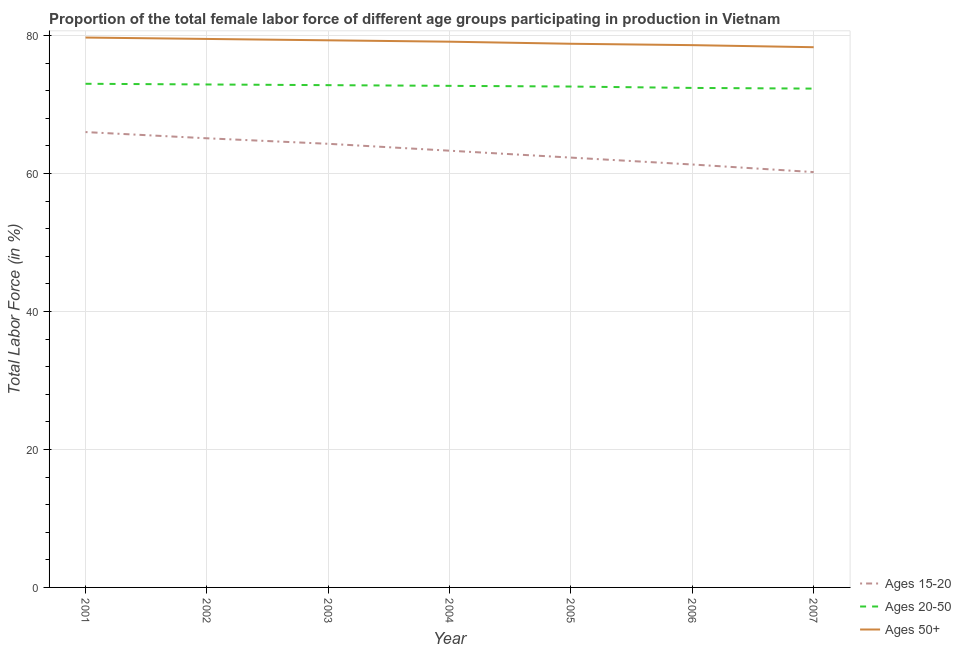How many different coloured lines are there?
Offer a terse response. 3. What is the percentage of female labor force within the age group 15-20 in 2002?
Provide a short and direct response. 65.1. Across all years, what is the maximum percentage of female labor force above age 50?
Your answer should be compact. 79.7. Across all years, what is the minimum percentage of female labor force within the age group 20-50?
Keep it short and to the point. 72.3. In which year was the percentage of female labor force above age 50 maximum?
Your answer should be compact. 2001. What is the total percentage of female labor force within the age group 15-20 in the graph?
Make the answer very short. 442.5. What is the difference between the percentage of female labor force within the age group 15-20 in 2001 and that in 2003?
Your answer should be very brief. 1.7. What is the difference between the percentage of female labor force above age 50 in 2001 and the percentage of female labor force within the age group 15-20 in 2003?
Your response must be concise. 15.4. What is the average percentage of female labor force within the age group 15-20 per year?
Ensure brevity in your answer.  63.21. In the year 2007, what is the difference between the percentage of female labor force within the age group 20-50 and percentage of female labor force within the age group 15-20?
Provide a succinct answer. 12.1. In how many years, is the percentage of female labor force within the age group 15-20 greater than 28 %?
Your response must be concise. 7. What is the ratio of the percentage of female labor force above age 50 in 2004 to that in 2006?
Offer a terse response. 1.01. Is the difference between the percentage of female labor force within the age group 15-20 in 2002 and 2005 greater than the difference between the percentage of female labor force within the age group 20-50 in 2002 and 2005?
Ensure brevity in your answer.  Yes. What is the difference between the highest and the second highest percentage of female labor force above age 50?
Provide a short and direct response. 0.2. What is the difference between the highest and the lowest percentage of female labor force above age 50?
Provide a succinct answer. 1.4. In how many years, is the percentage of female labor force within the age group 20-50 greater than the average percentage of female labor force within the age group 20-50 taken over all years?
Your response must be concise. 4. Is it the case that in every year, the sum of the percentage of female labor force within the age group 15-20 and percentage of female labor force within the age group 20-50 is greater than the percentage of female labor force above age 50?
Provide a succinct answer. Yes. Is the percentage of female labor force above age 50 strictly less than the percentage of female labor force within the age group 15-20 over the years?
Your response must be concise. No. How many years are there in the graph?
Ensure brevity in your answer.  7. What is the difference between two consecutive major ticks on the Y-axis?
Give a very brief answer. 20. How are the legend labels stacked?
Offer a terse response. Vertical. What is the title of the graph?
Provide a succinct answer. Proportion of the total female labor force of different age groups participating in production in Vietnam. Does "Unemployment benefits" appear as one of the legend labels in the graph?
Provide a succinct answer. No. What is the Total Labor Force (in %) in Ages 15-20 in 2001?
Keep it short and to the point. 66. What is the Total Labor Force (in %) in Ages 50+ in 2001?
Your response must be concise. 79.7. What is the Total Labor Force (in %) in Ages 15-20 in 2002?
Provide a short and direct response. 65.1. What is the Total Labor Force (in %) in Ages 20-50 in 2002?
Your response must be concise. 72.9. What is the Total Labor Force (in %) of Ages 50+ in 2002?
Your answer should be very brief. 79.5. What is the Total Labor Force (in %) in Ages 15-20 in 2003?
Your answer should be very brief. 64.3. What is the Total Labor Force (in %) in Ages 20-50 in 2003?
Offer a very short reply. 72.8. What is the Total Labor Force (in %) of Ages 50+ in 2003?
Give a very brief answer. 79.3. What is the Total Labor Force (in %) in Ages 15-20 in 2004?
Your answer should be compact. 63.3. What is the Total Labor Force (in %) of Ages 20-50 in 2004?
Your answer should be very brief. 72.7. What is the Total Labor Force (in %) of Ages 50+ in 2004?
Your answer should be compact. 79.1. What is the Total Labor Force (in %) of Ages 15-20 in 2005?
Offer a terse response. 62.3. What is the Total Labor Force (in %) of Ages 20-50 in 2005?
Your answer should be compact. 72.6. What is the Total Labor Force (in %) in Ages 50+ in 2005?
Give a very brief answer. 78.8. What is the Total Labor Force (in %) in Ages 15-20 in 2006?
Your answer should be very brief. 61.3. What is the Total Labor Force (in %) of Ages 20-50 in 2006?
Keep it short and to the point. 72.4. What is the Total Labor Force (in %) of Ages 50+ in 2006?
Make the answer very short. 78.6. What is the Total Labor Force (in %) of Ages 15-20 in 2007?
Offer a terse response. 60.2. What is the Total Labor Force (in %) of Ages 20-50 in 2007?
Ensure brevity in your answer.  72.3. What is the Total Labor Force (in %) of Ages 50+ in 2007?
Your response must be concise. 78.3. Across all years, what is the maximum Total Labor Force (in %) in Ages 15-20?
Provide a short and direct response. 66. Across all years, what is the maximum Total Labor Force (in %) of Ages 50+?
Give a very brief answer. 79.7. Across all years, what is the minimum Total Labor Force (in %) of Ages 15-20?
Your answer should be very brief. 60.2. Across all years, what is the minimum Total Labor Force (in %) in Ages 20-50?
Ensure brevity in your answer.  72.3. Across all years, what is the minimum Total Labor Force (in %) of Ages 50+?
Your answer should be very brief. 78.3. What is the total Total Labor Force (in %) in Ages 15-20 in the graph?
Your answer should be compact. 442.5. What is the total Total Labor Force (in %) of Ages 20-50 in the graph?
Ensure brevity in your answer.  508.7. What is the total Total Labor Force (in %) of Ages 50+ in the graph?
Keep it short and to the point. 553.3. What is the difference between the Total Labor Force (in %) of Ages 20-50 in 2001 and that in 2002?
Provide a succinct answer. 0.1. What is the difference between the Total Labor Force (in %) in Ages 20-50 in 2001 and that in 2003?
Your response must be concise. 0.2. What is the difference between the Total Labor Force (in %) of Ages 15-20 in 2001 and that in 2004?
Ensure brevity in your answer.  2.7. What is the difference between the Total Labor Force (in %) in Ages 20-50 in 2001 and that in 2004?
Offer a very short reply. 0.3. What is the difference between the Total Labor Force (in %) of Ages 15-20 in 2001 and that in 2005?
Provide a short and direct response. 3.7. What is the difference between the Total Labor Force (in %) of Ages 50+ in 2001 and that in 2005?
Your answer should be very brief. 0.9. What is the difference between the Total Labor Force (in %) in Ages 15-20 in 2001 and that in 2006?
Ensure brevity in your answer.  4.7. What is the difference between the Total Labor Force (in %) of Ages 15-20 in 2001 and that in 2007?
Offer a terse response. 5.8. What is the difference between the Total Labor Force (in %) of Ages 50+ in 2001 and that in 2007?
Your answer should be very brief. 1.4. What is the difference between the Total Labor Force (in %) of Ages 15-20 in 2002 and that in 2003?
Provide a short and direct response. 0.8. What is the difference between the Total Labor Force (in %) of Ages 20-50 in 2002 and that in 2003?
Your answer should be compact. 0.1. What is the difference between the Total Labor Force (in %) in Ages 15-20 in 2002 and that in 2004?
Your response must be concise. 1.8. What is the difference between the Total Labor Force (in %) of Ages 20-50 in 2002 and that in 2004?
Offer a terse response. 0.2. What is the difference between the Total Labor Force (in %) in Ages 50+ in 2002 and that in 2004?
Your response must be concise. 0.4. What is the difference between the Total Labor Force (in %) in Ages 15-20 in 2002 and that in 2005?
Keep it short and to the point. 2.8. What is the difference between the Total Labor Force (in %) in Ages 50+ in 2002 and that in 2005?
Your response must be concise. 0.7. What is the difference between the Total Labor Force (in %) of Ages 15-20 in 2002 and that in 2006?
Keep it short and to the point. 3.8. What is the difference between the Total Labor Force (in %) of Ages 20-50 in 2002 and that in 2006?
Make the answer very short. 0.5. What is the difference between the Total Labor Force (in %) of Ages 50+ in 2002 and that in 2006?
Ensure brevity in your answer.  0.9. What is the difference between the Total Labor Force (in %) of Ages 20-50 in 2003 and that in 2004?
Your answer should be very brief. 0.1. What is the difference between the Total Labor Force (in %) of Ages 50+ in 2003 and that in 2004?
Ensure brevity in your answer.  0.2. What is the difference between the Total Labor Force (in %) in Ages 15-20 in 2003 and that in 2005?
Ensure brevity in your answer.  2. What is the difference between the Total Labor Force (in %) in Ages 20-50 in 2003 and that in 2005?
Ensure brevity in your answer.  0.2. What is the difference between the Total Labor Force (in %) of Ages 50+ in 2003 and that in 2005?
Provide a succinct answer. 0.5. What is the difference between the Total Labor Force (in %) of Ages 15-20 in 2003 and that in 2006?
Offer a terse response. 3. What is the difference between the Total Labor Force (in %) of Ages 50+ in 2003 and that in 2006?
Make the answer very short. 0.7. What is the difference between the Total Labor Force (in %) in Ages 20-50 in 2003 and that in 2007?
Give a very brief answer. 0.5. What is the difference between the Total Labor Force (in %) of Ages 15-20 in 2004 and that in 2005?
Ensure brevity in your answer.  1. What is the difference between the Total Labor Force (in %) in Ages 15-20 in 2004 and that in 2007?
Ensure brevity in your answer.  3.1. What is the difference between the Total Labor Force (in %) in Ages 50+ in 2004 and that in 2007?
Your response must be concise. 0.8. What is the difference between the Total Labor Force (in %) of Ages 50+ in 2005 and that in 2006?
Your answer should be compact. 0.2. What is the difference between the Total Labor Force (in %) in Ages 15-20 in 2005 and that in 2007?
Offer a very short reply. 2.1. What is the difference between the Total Labor Force (in %) of Ages 20-50 in 2005 and that in 2007?
Provide a short and direct response. 0.3. What is the difference between the Total Labor Force (in %) of Ages 50+ in 2006 and that in 2007?
Ensure brevity in your answer.  0.3. What is the difference between the Total Labor Force (in %) of Ages 15-20 in 2001 and the Total Labor Force (in %) of Ages 20-50 in 2003?
Give a very brief answer. -6.8. What is the difference between the Total Labor Force (in %) in Ages 15-20 in 2001 and the Total Labor Force (in %) in Ages 50+ in 2003?
Your answer should be very brief. -13.3. What is the difference between the Total Labor Force (in %) of Ages 15-20 in 2001 and the Total Labor Force (in %) of Ages 50+ in 2004?
Make the answer very short. -13.1. What is the difference between the Total Labor Force (in %) of Ages 20-50 in 2001 and the Total Labor Force (in %) of Ages 50+ in 2004?
Make the answer very short. -6.1. What is the difference between the Total Labor Force (in %) of Ages 15-20 in 2001 and the Total Labor Force (in %) of Ages 50+ in 2005?
Provide a succinct answer. -12.8. What is the difference between the Total Labor Force (in %) of Ages 20-50 in 2001 and the Total Labor Force (in %) of Ages 50+ in 2005?
Make the answer very short. -5.8. What is the difference between the Total Labor Force (in %) in Ages 15-20 in 2001 and the Total Labor Force (in %) in Ages 20-50 in 2006?
Your answer should be very brief. -6.4. What is the difference between the Total Labor Force (in %) in Ages 15-20 in 2001 and the Total Labor Force (in %) in Ages 50+ in 2007?
Keep it short and to the point. -12.3. What is the difference between the Total Labor Force (in %) in Ages 15-20 in 2002 and the Total Labor Force (in %) in Ages 20-50 in 2003?
Make the answer very short. -7.7. What is the difference between the Total Labor Force (in %) of Ages 15-20 in 2002 and the Total Labor Force (in %) of Ages 50+ in 2003?
Make the answer very short. -14.2. What is the difference between the Total Labor Force (in %) of Ages 20-50 in 2002 and the Total Labor Force (in %) of Ages 50+ in 2004?
Give a very brief answer. -6.2. What is the difference between the Total Labor Force (in %) of Ages 15-20 in 2002 and the Total Labor Force (in %) of Ages 50+ in 2005?
Your answer should be compact. -13.7. What is the difference between the Total Labor Force (in %) of Ages 20-50 in 2002 and the Total Labor Force (in %) of Ages 50+ in 2005?
Make the answer very short. -5.9. What is the difference between the Total Labor Force (in %) in Ages 15-20 in 2002 and the Total Labor Force (in %) in Ages 20-50 in 2006?
Provide a succinct answer. -7.3. What is the difference between the Total Labor Force (in %) in Ages 15-20 in 2002 and the Total Labor Force (in %) in Ages 50+ in 2007?
Ensure brevity in your answer.  -13.2. What is the difference between the Total Labor Force (in %) of Ages 15-20 in 2003 and the Total Labor Force (in %) of Ages 20-50 in 2004?
Your answer should be very brief. -8.4. What is the difference between the Total Labor Force (in %) in Ages 15-20 in 2003 and the Total Labor Force (in %) in Ages 50+ in 2004?
Keep it short and to the point. -14.8. What is the difference between the Total Labor Force (in %) of Ages 15-20 in 2003 and the Total Labor Force (in %) of Ages 20-50 in 2005?
Your answer should be very brief. -8.3. What is the difference between the Total Labor Force (in %) of Ages 15-20 in 2003 and the Total Labor Force (in %) of Ages 50+ in 2005?
Make the answer very short. -14.5. What is the difference between the Total Labor Force (in %) in Ages 20-50 in 2003 and the Total Labor Force (in %) in Ages 50+ in 2005?
Offer a terse response. -6. What is the difference between the Total Labor Force (in %) of Ages 15-20 in 2003 and the Total Labor Force (in %) of Ages 20-50 in 2006?
Offer a terse response. -8.1. What is the difference between the Total Labor Force (in %) of Ages 15-20 in 2003 and the Total Labor Force (in %) of Ages 50+ in 2006?
Ensure brevity in your answer.  -14.3. What is the difference between the Total Labor Force (in %) of Ages 15-20 in 2003 and the Total Labor Force (in %) of Ages 50+ in 2007?
Provide a succinct answer. -14. What is the difference between the Total Labor Force (in %) in Ages 20-50 in 2003 and the Total Labor Force (in %) in Ages 50+ in 2007?
Make the answer very short. -5.5. What is the difference between the Total Labor Force (in %) of Ages 15-20 in 2004 and the Total Labor Force (in %) of Ages 50+ in 2005?
Ensure brevity in your answer.  -15.5. What is the difference between the Total Labor Force (in %) in Ages 15-20 in 2004 and the Total Labor Force (in %) in Ages 20-50 in 2006?
Ensure brevity in your answer.  -9.1. What is the difference between the Total Labor Force (in %) of Ages 15-20 in 2004 and the Total Labor Force (in %) of Ages 50+ in 2006?
Your response must be concise. -15.3. What is the difference between the Total Labor Force (in %) of Ages 20-50 in 2004 and the Total Labor Force (in %) of Ages 50+ in 2006?
Provide a succinct answer. -5.9. What is the difference between the Total Labor Force (in %) of Ages 15-20 in 2004 and the Total Labor Force (in %) of Ages 20-50 in 2007?
Offer a terse response. -9. What is the difference between the Total Labor Force (in %) in Ages 15-20 in 2005 and the Total Labor Force (in %) in Ages 50+ in 2006?
Your answer should be compact. -16.3. What is the difference between the Total Labor Force (in %) in Ages 15-20 in 2005 and the Total Labor Force (in %) in Ages 20-50 in 2007?
Offer a very short reply. -10. What is the difference between the Total Labor Force (in %) of Ages 15-20 in 2006 and the Total Labor Force (in %) of Ages 20-50 in 2007?
Offer a very short reply. -11. What is the difference between the Total Labor Force (in %) of Ages 15-20 in 2006 and the Total Labor Force (in %) of Ages 50+ in 2007?
Give a very brief answer. -17. What is the difference between the Total Labor Force (in %) of Ages 20-50 in 2006 and the Total Labor Force (in %) of Ages 50+ in 2007?
Give a very brief answer. -5.9. What is the average Total Labor Force (in %) in Ages 15-20 per year?
Your response must be concise. 63.21. What is the average Total Labor Force (in %) in Ages 20-50 per year?
Your answer should be compact. 72.67. What is the average Total Labor Force (in %) of Ages 50+ per year?
Make the answer very short. 79.04. In the year 2001, what is the difference between the Total Labor Force (in %) of Ages 15-20 and Total Labor Force (in %) of Ages 50+?
Your response must be concise. -13.7. In the year 2002, what is the difference between the Total Labor Force (in %) in Ages 15-20 and Total Labor Force (in %) in Ages 50+?
Keep it short and to the point. -14.4. In the year 2002, what is the difference between the Total Labor Force (in %) of Ages 20-50 and Total Labor Force (in %) of Ages 50+?
Make the answer very short. -6.6. In the year 2003, what is the difference between the Total Labor Force (in %) of Ages 20-50 and Total Labor Force (in %) of Ages 50+?
Your answer should be compact. -6.5. In the year 2004, what is the difference between the Total Labor Force (in %) in Ages 15-20 and Total Labor Force (in %) in Ages 20-50?
Provide a short and direct response. -9.4. In the year 2004, what is the difference between the Total Labor Force (in %) in Ages 15-20 and Total Labor Force (in %) in Ages 50+?
Give a very brief answer. -15.8. In the year 2004, what is the difference between the Total Labor Force (in %) in Ages 20-50 and Total Labor Force (in %) in Ages 50+?
Give a very brief answer. -6.4. In the year 2005, what is the difference between the Total Labor Force (in %) of Ages 15-20 and Total Labor Force (in %) of Ages 20-50?
Offer a terse response. -10.3. In the year 2005, what is the difference between the Total Labor Force (in %) of Ages 15-20 and Total Labor Force (in %) of Ages 50+?
Provide a succinct answer. -16.5. In the year 2006, what is the difference between the Total Labor Force (in %) in Ages 15-20 and Total Labor Force (in %) in Ages 20-50?
Offer a terse response. -11.1. In the year 2006, what is the difference between the Total Labor Force (in %) in Ages 15-20 and Total Labor Force (in %) in Ages 50+?
Keep it short and to the point. -17.3. In the year 2007, what is the difference between the Total Labor Force (in %) of Ages 15-20 and Total Labor Force (in %) of Ages 50+?
Keep it short and to the point. -18.1. In the year 2007, what is the difference between the Total Labor Force (in %) in Ages 20-50 and Total Labor Force (in %) in Ages 50+?
Give a very brief answer. -6. What is the ratio of the Total Labor Force (in %) of Ages 15-20 in 2001 to that in 2002?
Provide a succinct answer. 1.01. What is the ratio of the Total Labor Force (in %) in Ages 50+ in 2001 to that in 2002?
Make the answer very short. 1. What is the ratio of the Total Labor Force (in %) in Ages 15-20 in 2001 to that in 2003?
Provide a succinct answer. 1.03. What is the ratio of the Total Labor Force (in %) of Ages 20-50 in 2001 to that in 2003?
Your answer should be compact. 1. What is the ratio of the Total Labor Force (in %) in Ages 50+ in 2001 to that in 2003?
Offer a terse response. 1. What is the ratio of the Total Labor Force (in %) in Ages 15-20 in 2001 to that in 2004?
Your answer should be very brief. 1.04. What is the ratio of the Total Labor Force (in %) in Ages 50+ in 2001 to that in 2004?
Make the answer very short. 1.01. What is the ratio of the Total Labor Force (in %) in Ages 15-20 in 2001 to that in 2005?
Provide a short and direct response. 1.06. What is the ratio of the Total Labor Force (in %) of Ages 20-50 in 2001 to that in 2005?
Provide a short and direct response. 1.01. What is the ratio of the Total Labor Force (in %) of Ages 50+ in 2001 to that in 2005?
Provide a succinct answer. 1.01. What is the ratio of the Total Labor Force (in %) of Ages 15-20 in 2001 to that in 2006?
Ensure brevity in your answer.  1.08. What is the ratio of the Total Labor Force (in %) in Ages 20-50 in 2001 to that in 2006?
Offer a terse response. 1.01. What is the ratio of the Total Labor Force (in %) of Ages 15-20 in 2001 to that in 2007?
Make the answer very short. 1.1. What is the ratio of the Total Labor Force (in %) of Ages 20-50 in 2001 to that in 2007?
Your response must be concise. 1.01. What is the ratio of the Total Labor Force (in %) in Ages 50+ in 2001 to that in 2007?
Make the answer very short. 1.02. What is the ratio of the Total Labor Force (in %) of Ages 15-20 in 2002 to that in 2003?
Your response must be concise. 1.01. What is the ratio of the Total Labor Force (in %) of Ages 50+ in 2002 to that in 2003?
Offer a terse response. 1. What is the ratio of the Total Labor Force (in %) in Ages 15-20 in 2002 to that in 2004?
Give a very brief answer. 1.03. What is the ratio of the Total Labor Force (in %) of Ages 50+ in 2002 to that in 2004?
Keep it short and to the point. 1.01. What is the ratio of the Total Labor Force (in %) of Ages 15-20 in 2002 to that in 2005?
Provide a succinct answer. 1.04. What is the ratio of the Total Labor Force (in %) of Ages 50+ in 2002 to that in 2005?
Offer a very short reply. 1.01. What is the ratio of the Total Labor Force (in %) in Ages 15-20 in 2002 to that in 2006?
Ensure brevity in your answer.  1.06. What is the ratio of the Total Labor Force (in %) of Ages 20-50 in 2002 to that in 2006?
Keep it short and to the point. 1.01. What is the ratio of the Total Labor Force (in %) of Ages 50+ in 2002 to that in 2006?
Provide a short and direct response. 1.01. What is the ratio of the Total Labor Force (in %) of Ages 15-20 in 2002 to that in 2007?
Your answer should be very brief. 1.08. What is the ratio of the Total Labor Force (in %) in Ages 20-50 in 2002 to that in 2007?
Your answer should be very brief. 1.01. What is the ratio of the Total Labor Force (in %) of Ages 50+ in 2002 to that in 2007?
Make the answer very short. 1.02. What is the ratio of the Total Labor Force (in %) in Ages 15-20 in 2003 to that in 2004?
Offer a very short reply. 1.02. What is the ratio of the Total Labor Force (in %) of Ages 15-20 in 2003 to that in 2005?
Provide a succinct answer. 1.03. What is the ratio of the Total Labor Force (in %) of Ages 20-50 in 2003 to that in 2005?
Your answer should be compact. 1. What is the ratio of the Total Labor Force (in %) of Ages 50+ in 2003 to that in 2005?
Ensure brevity in your answer.  1.01. What is the ratio of the Total Labor Force (in %) of Ages 15-20 in 2003 to that in 2006?
Your answer should be very brief. 1.05. What is the ratio of the Total Labor Force (in %) in Ages 20-50 in 2003 to that in 2006?
Ensure brevity in your answer.  1.01. What is the ratio of the Total Labor Force (in %) of Ages 50+ in 2003 to that in 2006?
Keep it short and to the point. 1.01. What is the ratio of the Total Labor Force (in %) in Ages 15-20 in 2003 to that in 2007?
Provide a short and direct response. 1.07. What is the ratio of the Total Labor Force (in %) of Ages 20-50 in 2003 to that in 2007?
Give a very brief answer. 1.01. What is the ratio of the Total Labor Force (in %) in Ages 50+ in 2003 to that in 2007?
Provide a succinct answer. 1.01. What is the ratio of the Total Labor Force (in %) in Ages 15-20 in 2004 to that in 2005?
Ensure brevity in your answer.  1.02. What is the ratio of the Total Labor Force (in %) of Ages 50+ in 2004 to that in 2005?
Your response must be concise. 1. What is the ratio of the Total Labor Force (in %) in Ages 15-20 in 2004 to that in 2006?
Keep it short and to the point. 1.03. What is the ratio of the Total Labor Force (in %) in Ages 50+ in 2004 to that in 2006?
Provide a succinct answer. 1.01. What is the ratio of the Total Labor Force (in %) in Ages 15-20 in 2004 to that in 2007?
Ensure brevity in your answer.  1.05. What is the ratio of the Total Labor Force (in %) of Ages 50+ in 2004 to that in 2007?
Give a very brief answer. 1.01. What is the ratio of the Total Labor Force (in %) of Ages 15-20 in 2005 to that in 2006?
Keep it short and to the point. 1.02. What is the ratio of the Total Labor Force (in %) of Ages 20-50 in 2005 to that in 2006?
Your answer should be very brief. 1. What is the ratio of the Total Labor Force (in %) in Ages 15-20 in 2005 to that in 2007?
Give a very brief answer. 1.03. What is the ratio of the Total Labor Force (in %) of Ages 50+ in 2005 to that in 2007?
Offer a very short reply. 1.01. What is the ratio of the Total Labor Force (in %) of Ages 15-20 in 2006 to that in 2007?
Keep it short and to the point. 1.02. What is the difference between the highest and the second highest Total Labor Force (in %) in Ages 20-50?
Provide a short and direct response. 0.1. What is the difference between the highest and the second highest Total Labor Force (in %) in Ages 50+?
Provide a succinct answer. 0.2. 